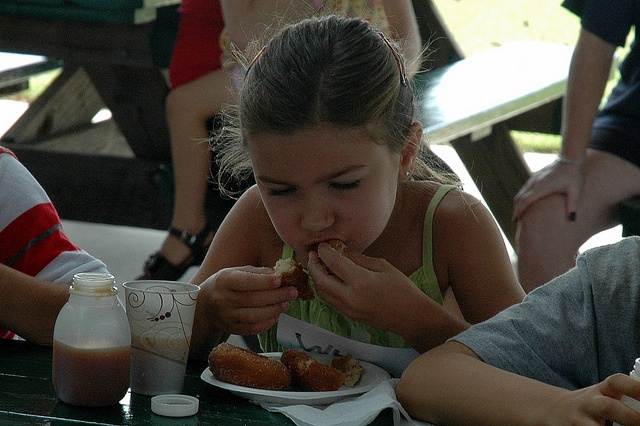Describe the objects in this image and their specific colors. I can see people in black, maroon, and gray tones, dining table in black, gray, and maroon tones, people in black and gray tones, people in black and gray tones, and bench in black and gray tones in this image. 